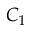Convert formula to latex. <formula><loc_0><loc_0><loc_500><loc_500>C _ { 1 }</formula> 